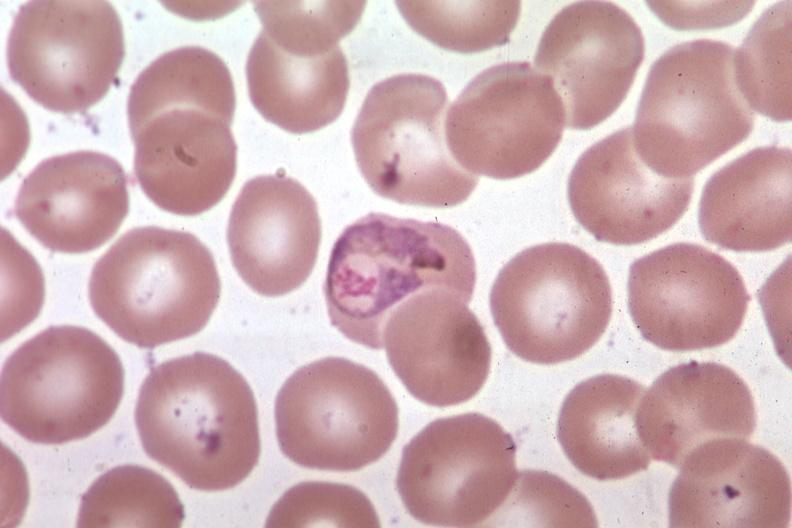s malaria plasmodium vivax present?
Answer the question using a single word or phrase. Yes 